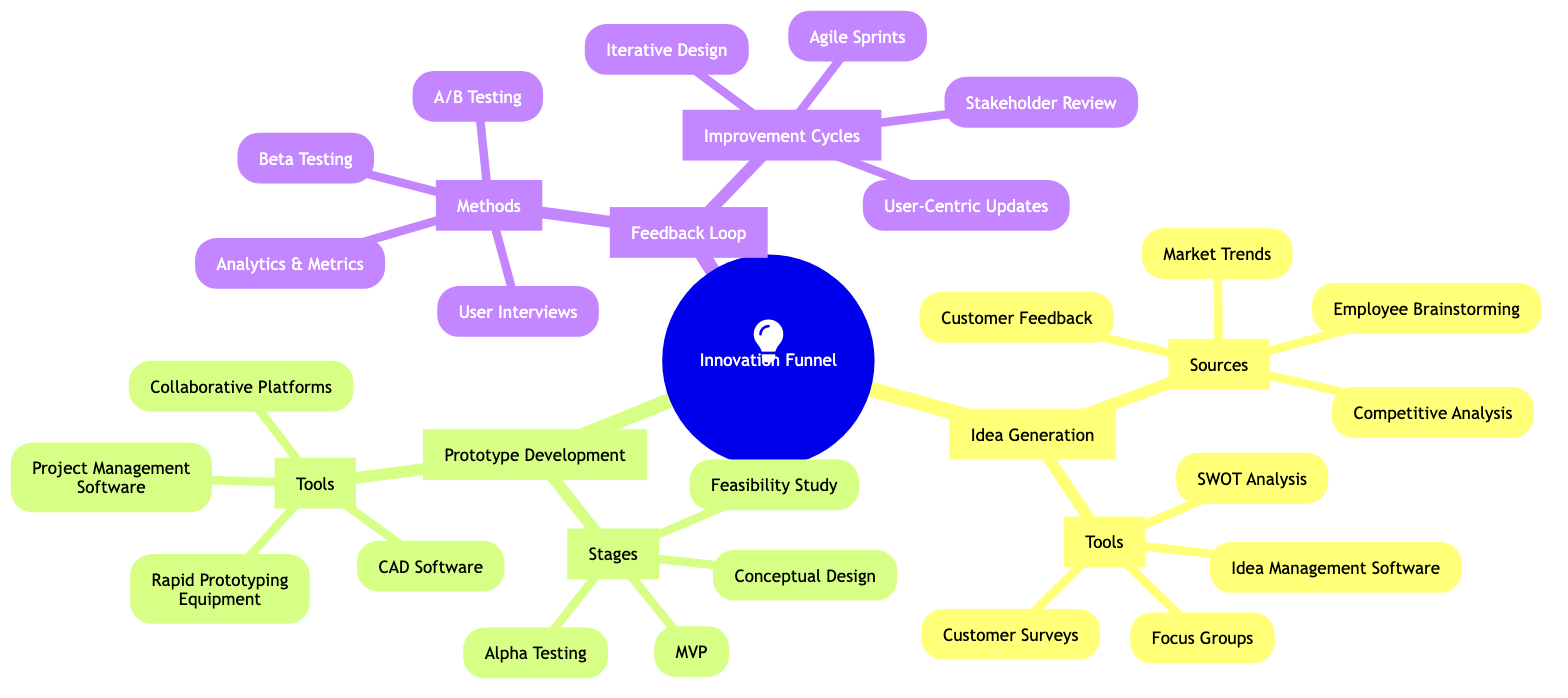What are the sources for Idea Generation? The diagram lists four sources under Idea Generation: Customer Feedback, Market Trends, Employee Brainstorming, and Competitive Analysis. This information is directly found by looking at the node labeled "Sources" which branches out to these four items.
Answer: Customer Feedback, Market Trends, Employee Brainstorming, Competitive Analysis How many stages are there in Prototype Development? Under the Prototype Development section, there is a node labeled "Stages" that includes four distinct stages: Conceptual Design, Feasibility Study, MVP, and Alpha Testing. Thus, counting these items gives the total number of stages.
Answer: 4 Which tool is used for Feedback Loop? The Feedback Loop section contains a node labeled "Methods" listing Beta Testing, A/B Testing, User Interviews, and Analytics & Metrics, which suggests these are the methods used in the feedback collection process. This is derived from identifying the tools listed in the Feedback Loop.
Answer: Beta Testing, A/B Testing, User Interviews, Analytics & Metrics What is the last stage in Prototype Development? By examining the stages within the Prototype Development section, the stages are presented in a specific order, with the last one being Alpha Testing. Thus, identifying the order confirms this fact.
Answer: Alpha Testing How many improvement cycles are detailed in the Feedback Loop? The Feedback Loop section has a node labeled "Improvement Cycles" that outlines four specific types: Iterative Design, User-Centric Updates, Agile Sprints, and Stakeholder Review. Counting the list items provides the total.
Answer: 4 What is the relationship between Idea Generation and Prototype Development? The relationship is that Idea Generation feeds into the Prototype Development stage, as it is the first part of the Innovation Funnel, suggesting that ideas generated are then conceptualized and developed into prototypes. This can be concluded from the sequence of sections in the Mind Map.
Answer: Idea Generation feeds into Prototype Development Which tool is common for both Prototype Development and Idea Generation? After reviewing both sections, neither section lists common tools; they each have distinct sets tailored to their respective stages. Therefore, examining the listed tools in each part reveals no overlaps.
Answer: None List one method used in the Feedback Loop. The diagram specifically mentions four methods under the Feedback Loop, including Beta Testing, A/B Testing, User Interviews, and Analytics & Metrics. Any one of these can be used to answer the question accurately.
Answer: Beta Testing (or any of the other methods listed) 